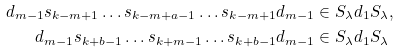Convert formula to latex. <formula><loc_0><loc_0><loc_500><loc_500>d _ { m - 1 } s _ { k - m + 1 } \dots s _ { k - m + a - 1 } \dots s _ { k - m + 1 } d _ { m - 1 } & \in S _ { \lambda } d _ { 1 } S _ { \lambda } , \\ d _ { m - 1 } s _ { k + b - 1 } \dots s _ { k + m - 1 } \dots s _ { k + b - 1 } d _ { m - 1 } & \in S _ { \lambda } d _ { 1 } S _ { \lambda }</formula> 